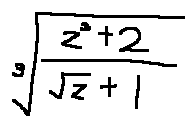Convert formula to latex. <formula><loc_0><loc_0><loc_500><loc_500>\sqrt { [ } 3 ] { \frac { z ^ { 3 } + 2 } { \sqrt { z } + 1 } }</formula> 